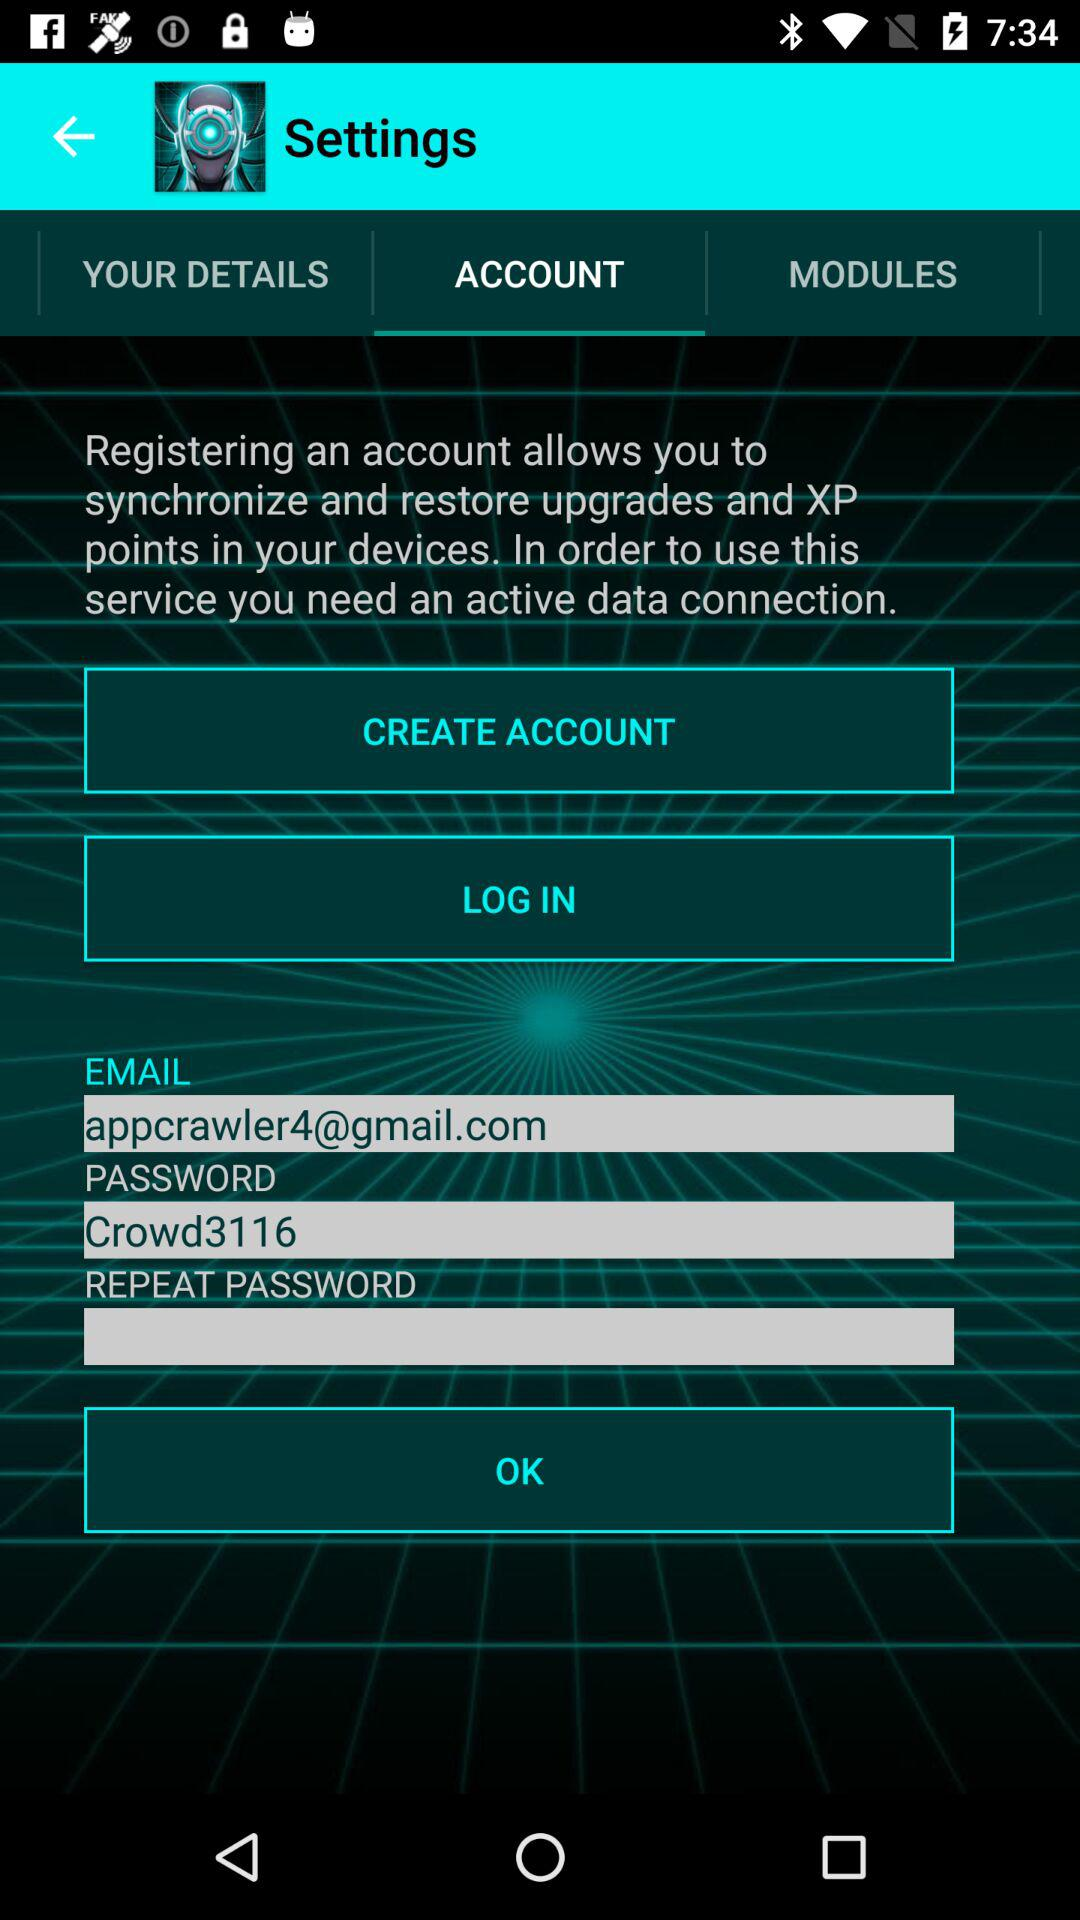What is the password shown on the screen? The password shown on the screen is "Crowd3116". 